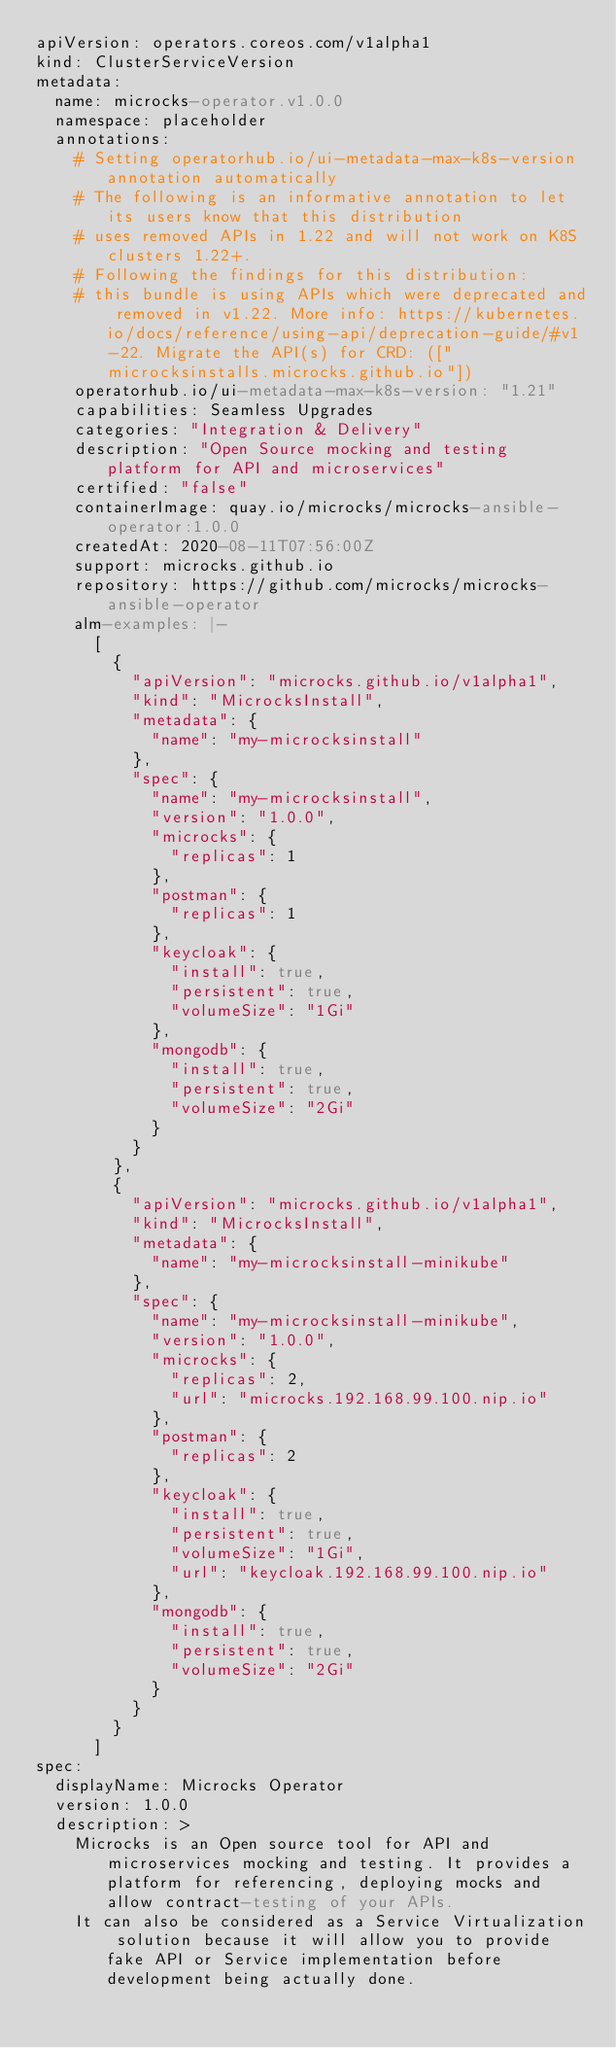<code> <loc_0><loc_0><loc_500><loc_500><_YAML_>apiVersion: operators.coreos.com/v1alpha1
kind: ClusterServiceVersion
metadata:
  name: microcks-operator.v1.0.0
  namespace: placeholder
  annotations:
    # Setting operatorhub.io/ui-metadata-max-k8s-version annotation automatically
    # The following is an informative annotation to let its users know that this distribution
    # uses removed APIs in 1.22 and will not work on K8S clusters 1.22+.
    # Following the findings for this distribution:
    # this bundle is using APIs which were deprecated and removed in v1.22. More info: https://kubernetes.io/docs/reference/using-api/deprecation-guide/#v1-22. Migrate the API(s) for CRD: (["microcksinstalls.microcks.github.io"])
    operatorhub.io/ui-metadata-max-k8s-version: "1.21"
    capabilities: Seamless Upgrades
    categories: "Integration & Delivery"
    description: "Open Source mocking and testing platform for API and microservices"
    certified: "false"
    containerImage: quay.io/microcks/microcks-ansible-operator:1.0.0
    createdAt: 2020-08-11T07:56:00Z
    support: microcks.github.io
    repository: https://github.com/microcks/microcks-ansible-operator
    alm-examples: |-
      [
        {
          "apiVersion": "microcks.github.io/v1alpha1",
          "kind": "MicrocksInstall",
          "metadata": {
            "name": "my-microcksinstall"
          },
          "spec": {
            "name": "my-microcksinstall",
            "version": "1.0.0",
            "microcks": {
              "replicas": 1
            },
            "postman": {
              "replicas": 1
            },
            "keycloak": {
              "install": true,
              "persistent": true,
              "volumeSize": "1Gi"
            },
            "mongodb": {
              "install": true,
              "persistent": true,
              "volumeSize": "2Gi"
            }
          }
        },
        {
          "apiVersion": "microcks.github.io/v1alpha1",
          "kind": "MicrocksInstall",
          "metadata": {
            "name": "my-microcksinstall-minikube"
          },
          "spec": {
            "name": "my-microcksinstall-minikube",
            "version": "1.0.0",
            "microcks": {
              "replicas": 2,
              "url": "microcks.192.168.99.100.nip.io"
            },
            "postman": {
              "replicas": 2
            },
            "keycloak": {
              "install": true,
              "persistent": true,
              "volumeSize": "1Gi",
              "url": "keycloak.192.168.99.100.nip.io"
            },
            "mongodb": {
              "install": true,
              "persistent": true,
              "volumeSize": "2Gi"
            }
          }
        }
      ]
spec:
  displayName: Microcks Operator
  version: 1.0.0
  description: >
    Microcks is an Open source tool for API and microservices mocking and testing. It provides a platform for referencing, deploying mocks and allow contract-testing of your APIs.
    It can also be considered as a Service Virtualization solution because it will allow you to provide fake API or Service implementation before development being actually done.</code> 